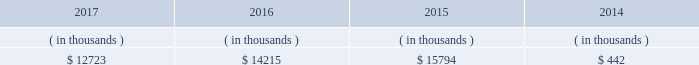The city council 2019s advisors and entergy new orleans .
In february 2018 the city council approved the settlement , which deferred cost recovery to the 2018 entergy new orleans rate case , but also stated that an adjustment for 2018-2019 ami costs can be filed in the rate case and that , for all subsequent ami costs , the mechanism to be approved in the 2018 rate case will allow for the timely recovery of such costs .
Sources of capital entergy new orleans 2019s sources to meet its capital requirements include : 2022 internally generated funds ; 2022 cash on hand ; 2022 debt and preferred membership interest issuances ; and 2022 bank financing under new or existing facilities .
Entergy new orleans may refinance , redeem , or otherwise retire debt prior to maturity , to the extent market conditions and interest rates are favorable .
Entergy new orleans 2019s receivables from the money pool were as follows as of december 31 for each of the following years. .
See note 4 to the financial statements for a description of the money pool .
Entergy new orleans has a credit facility in the amount of $ 25 million scheduled to expire in november 2018 .
The credit facility allows entergy new orleans to issue letters of credit against $ 10 million of the borrowing capacity of the facility .
As of december 31 , 2017 , there were no cash borrowings and a $ 0.8 million letter of credit was outstanding under the facility .
In addition , entergy new orleans is a party to an uncommitted letter of credit facility as a means to post collateral to support its obligations to miso . a0 as of december 31 , 2017 , a $ 1.4 million letter of credit was outstanding under entergy new orleans 2019s letter of credit a0facility .
See note 4 to the financial statements for additional discussion of the credit facilities .
Entergy new orleans obtained authorization from the ferc through october 2019 for short-term borrowings not to exceed an aggregate amount of $ 150 million at any time outstanding and long-term borrowings and securities issuances .
See note 4 to the financial statements for further discussion of entergy new orleans 2019s short-term borrowing limits .
The long-term securities issuances of entergy new orleans are limited to amounts authorized not only by the ferc , but also by the city council , and the current city council authorization extends through june 2018 .
Entergy new orleans , llc and subsidiaries management 2019s financial discussion and analysis state and local rate regulation the rates that entergy new orleans charges for electricity and natural gas significantly influence its financial position , results of operations , and liquidity .
Entergy new orleans is regulated and the rates charged to its customers are determined in regulatory proceedings .
A governmental agency , the city council , is primarily responsible for approval of the rates charged to customers .
Retail rates see 201calgiers asset transfer 201d below for discussion of the algiers asset transfer .
As a provision of the settlement agreement approved by the city council in may 2015 providing for the algiers asset transfer , it was agreed that , with limited exceptions , no action may be taken with respect to entergy new orleans 2019s base rates until rates are implemented .
How much did entergy receive from the money pool between 2014 and 2017 ? ( in thousands $ )? 
Computations: (((12723 + 14215) + 15794) + 442)
Answer: 43174.0. The city council 2019s advisors and entergy new orleans .
In february 2018 the city council approved the settlement , which deferred cost recovery to the 2018 entergy new orleans rate case , but also stated that an adjustment for 2018-2019 ami costs can be filed in the rate case and that , for all subsequent ami costs , the mechanism to be approved in the 2018 rate case will allow for the timely recovery of such costs .
Sources of capital entergy new orleans 2019s sources to meet its capital requirements include : 2022 internally generated funds ; 2022 cash on hand ; 2022 debt and preferred membership interest issuances ; and 2022 bank financing under new or existing facilities .
Entergy new orleans may refinance , redeem , or otherwise retire debt prior to maturity , to the extent market conditions and interest rates are favorable .
Entergy new orleans 2019s receivables from the money pool were as follows as of december 31 for each of the following years. .
See note 4 to the financial statements for a description of the money pool .
Entergy new orleans has a credit facility in the amount of $ 25 million scheduled to expire in november 2018 .
The credit facility allows entergy new orleans to issue letters of credit against $ 10 million of the borrowing capacity of the facility .
As of december 31 , 2017 , there were no cash borrowings and a $ 0.8 million letter of credit was outstanding under the facility .
In addition , entergy new orleans is a party to an uncommitted letter of credit facility as a means to post collateral to support its obligations to miso . a0 as of december 31 , 2017 , a $ 1.4 million letter of credit was outstanding under entergy new orleans 2019s letter of credit a0facility .
See note 4 to the financial statements for additional discussion of the credit facilities .
Entergy new orleans obtained authorization from the ferc through october 2019 for short-term borrowings not to exceed an aggregate amount of $ 150 million at any time outstanding and long-term borrowings and securities issuances .
See note 4 to the financial statements for further discussion of entergy new orleans 2019s short-term borrowing limits .
The long-term securities issuances of entergy new orleans are limited to amounts authorized not only by the ferc , but also by the city council , and the current city council authorization extends through june 2018 .
Entergy new orleans , llc and subsidiaries management 2019s financial discussion and analysis state and local rate regulation the rates that entergy new orleans charges for electricity and natural gas significantly influence its financial position , results of operations , and liquidity .
Entergy new orleans is regulated and the rates charged to its customers are determined in regulatory proceedings .
A governmental agency , the city council , is primarily responsible for approval of the rates charged to customers .
Retail rates see 201calgiers asset transfer 201d below for discussion of the algiers asset transfer .
As a provision of the settlement agreement approved by the city council in may 2015 providing for the algiers asset transfer , it was agreed that , with limited exceptions , no action may be taken with respect to entergy new orleans 2019s base rates until rates are implemented .
What was the average entergy new orleans 2019s receivables from the money pool from 2014 to 2017? 
Computations: (12723 + 14215)
Answer: 26938.0. 